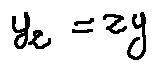<formula> <loc_0><loc_0><loc_500><loc_500>y z = z y</formula> 